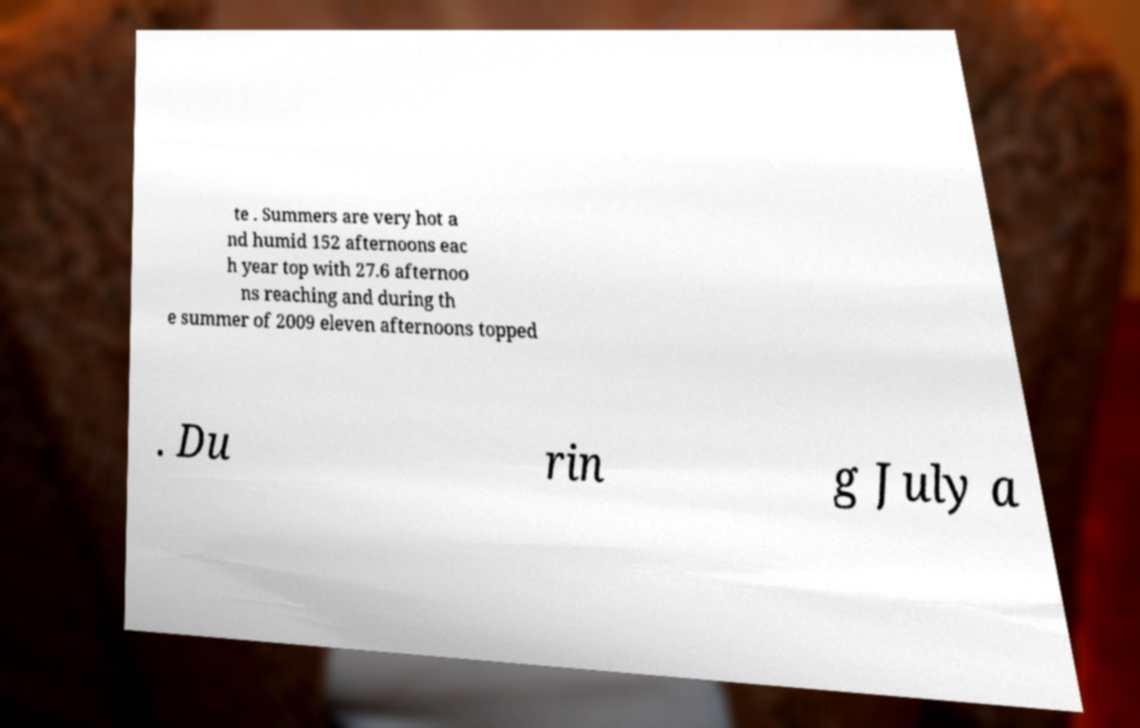For documentation purposes, I need the text within this image transcribed. Could you provide that? te . Summers are very hot a nd humid 152 afternoons eac h year top with 27.6 afternoo ns reaching and during th e summer of 2009 eleven afternoons topped . Du rin g July a 